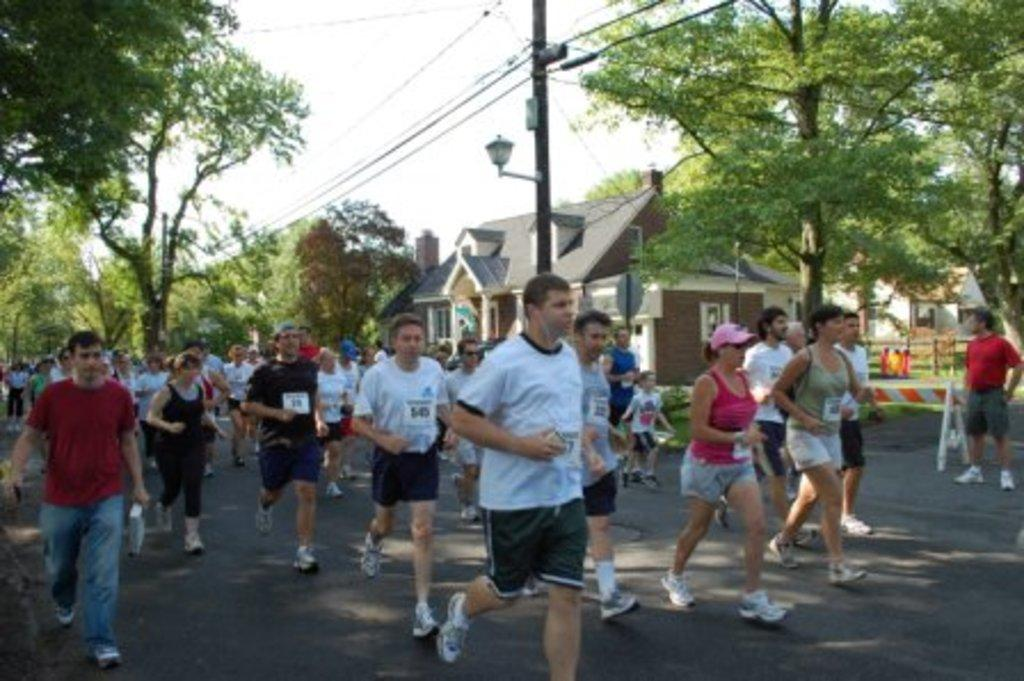What are the people in the image doing? The people in the image are running on the road. What can be seen beside the road in the image? There are houses and trees beside the road. What else can be seen in the image besides the people and the houses? There are electric poles with wires in the image. What type of soap is being used by the people running in the image? There is no soap present in the image, as the people are running on the road. What are the names of the people running in the image? The names of the people running in the image are not mentioned or visible, so it cannot be determined from the image. 